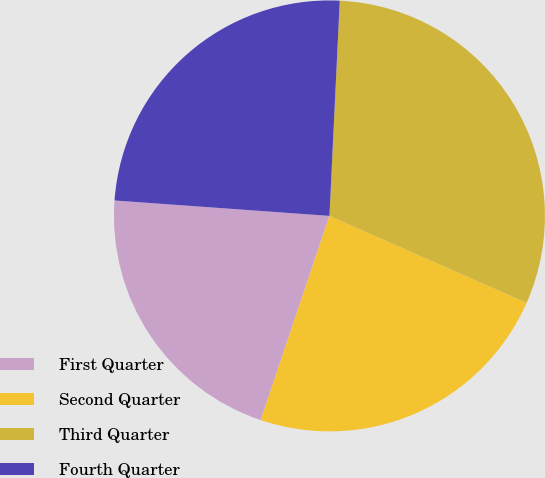Convert chart. <chart><loc_0><loc_0><loc_500><loc_500><pie_chart><fcel>First Quarter<fcel>Second Quarter<fcel>Third Quarter<fcel>Fourth Quarter<nl><fcel>20.97%<fcel>23.56%<fcel>30.85%<fcel>24.62%<nl></chart> 